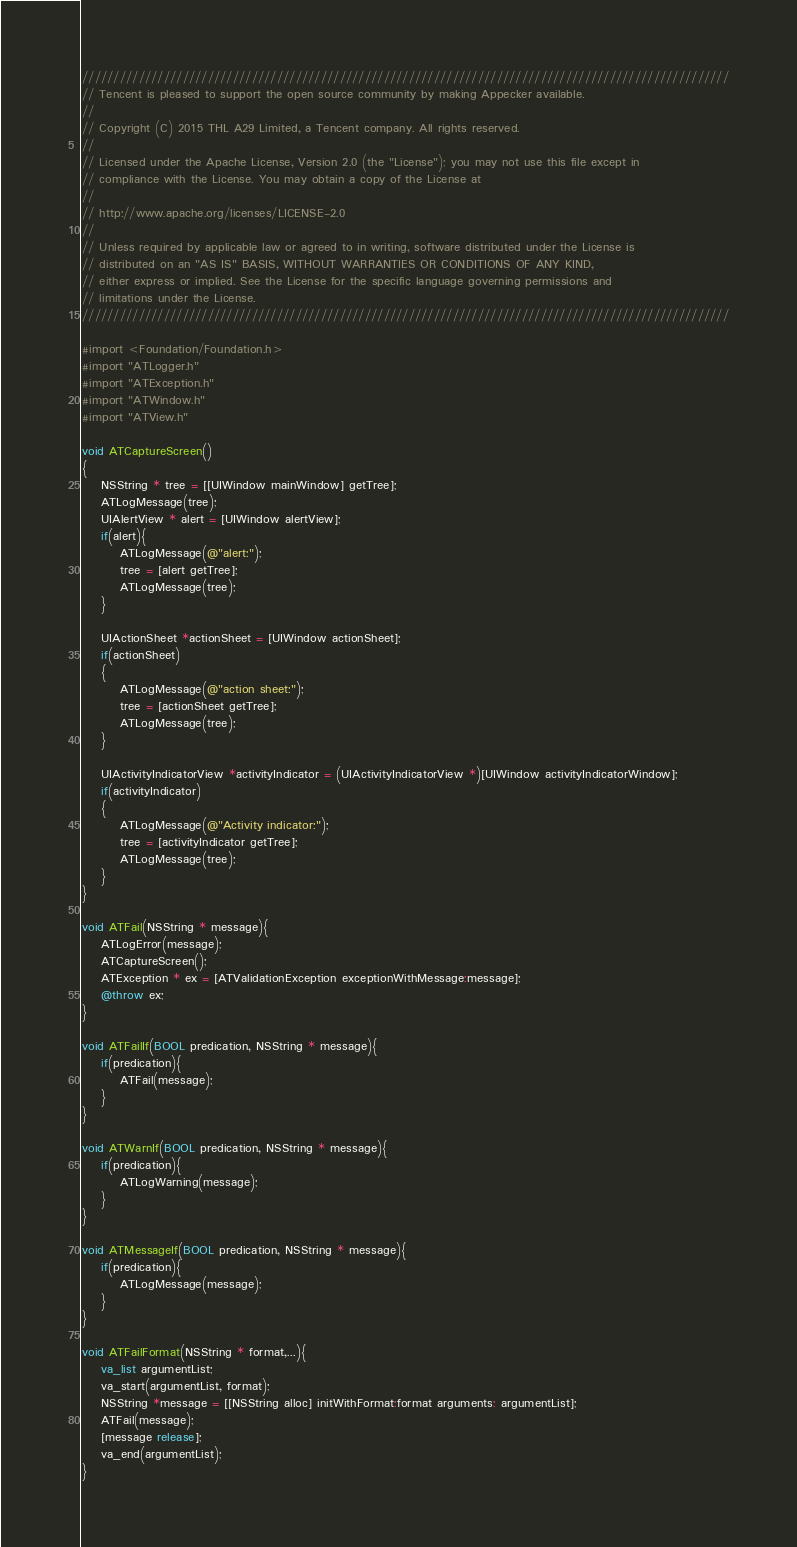Convert code to text. <code><loc_0><loc_0><loc_500><loc_500><_ObjectiveC_>///////////////////////////////////////////////////////////////////////////////////////////////////////
// Tencent is pleased to support the open source community by making Appecker available.
// 
// Copyright (C) 2015 THL A29 Limited, a Tencent company. All rights reserved.
// 
// Licensed under the Apache License, Version 2.0 (the "License"); you may not use this file except in
// compliance with the License. You may obtain a copy of the License at
// 
// http://www.apache.org/licenses/LICENSE-2.0
// 
// Unless required by applicable law or agreed to in writing, software distributed under the License is
// distributed on an "AS IS" BASIS, WITHOUT WARRANTIES OR CONDITIONS OF ANY KIND,
// either express or implied. See the License for the specific language governing permissions and
// limitations under the License.
///////////////////////////////////////////////////////////////////////////////////////////////////////

#import <Foundation/Foundation.h>
#import "ATLogger.h"
#import "ATException.h"
#import "ATWindow.h"
#import "ATView.h"

void ATCaptureScreen()
{
    NSString * tree = [[UIWindow mainWindow] getTree];
    ATLogMessage(tree);
    UIAlertView * alert = [UIWindow alertView];
    if(alert){
        ATLogMessage(@"alert:");
        tree = [alert getTree];
        ATLogMessage(tree);
    }

    UIActionSheet *actionSheet = [UIWindow actionSheet];
    if(actionSheet)
    {
        ATLogMessage(@"action sheet:");
        tree = [actionSheet getTree];
        ATLogMessage(tree);
    }

    UIActivityIndicatorView *activityIndicator = (UIActivityIndicatorView *)[UIWindow activityIndicatorWindow];
    if(activityIndicator)
    {
        ATLogMessage(@"Activity indicator:");
        tree = [activityIndicator getTree];
        ATLogMessage(tree);
    }
}

void ATFail(NSString * message){
    ATLogError(message);
    ATCaptureScreen();
    ATException * ex = [ATValidationException exceptionWithMessage:message];
    @throw ex;
}

void ATFailIf(BOOL predication, NSString * message){
    if(predication){
        ATFail(message);
    }
}

void ATWarnIf(BOOL predication, NSString * message){
    if(predication){
        ATLogWarning(message);
    }
}

void ATMessageIf(BOOL predication, NSString * message){
    if(predication){
        ATLogMessage(message);
    }
}

void ATFailFormat(NSString * format,...){
    va_list argumentList;
    va_start(argumentList, format);
    NSString *message = [[NSString alloc] initWithFormat:format arguments: argumentList];
    ATFail(message);
    [message release];
    va_end(argumentList);
}
</code> 